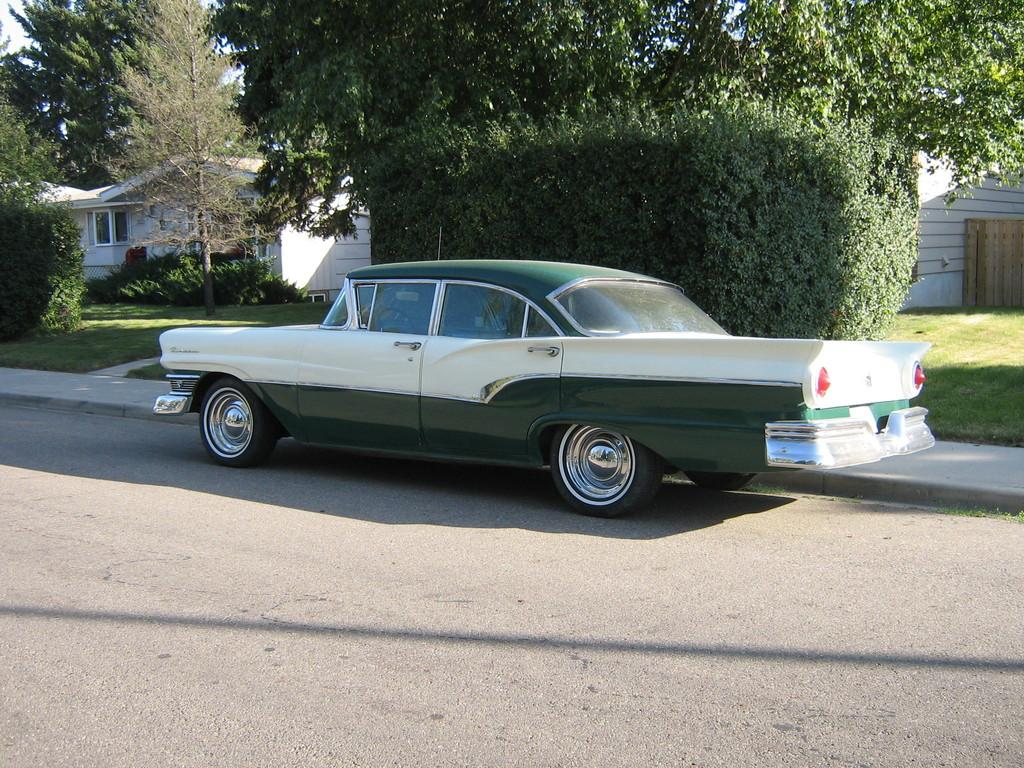What type of vehicle is in the image? There is a classic car in the image. What colors can be seen on the car? The car is white and green in color. Where is the car located in the image? The car is parked on the roadside. What can be seen in the background of the image? There are trees and a white color shade house visible in the background. How many fish were caught using the net in the image? There are no fish or nets present in the image; it features a classic car parked on the roadside. What time of day is depicted in the image? The provided facts do not mention the time of day, so it cannot be determined from the image. 